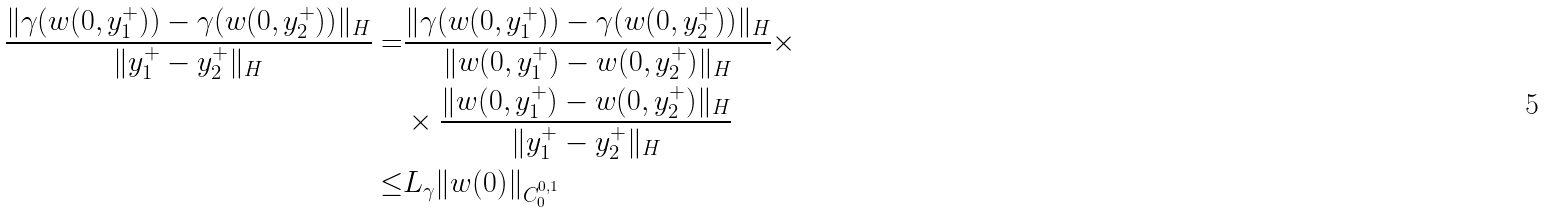<formula> <loc_0><loc_0><loc_500><loc_500>\frac { \| \gamma ( w ( 0 , y _ { 1 } ^ { + } ) ) - \gamma ( w ( 0 , y _ { 2 } ^ { + } ) ) \| _ { H } } { \| y _ { 1 } ^ { + } - y _ { 2 } ^ { + } \| _ { H } } = & \frac { \| \gamma ( w ( 0 , y _ { 1 } ^ { + } ) ) - \gamma ( w ( 0 , y _ { 2 } ^ { + } ) ) \| _ { H } } { \| w ( 0 , y _ { 1 } ^ { + } ) - w ( 0 , y _ { 2 } ^ { + } ) \| _ { H } } \times \\ & \times \frac { \| w ( 0 , y _ { 1 } ^ { + } ) - w ( 0 , y _ { 2 } ^ { + } ) \| _ { H } } { \| y _ { 1 } ^ { + } - y _ { 2 } ^ { + } \| _ { H } } \\ \leq & L _ { \gamma } \| w ( 0 ) \| _ { C _ { 0 } ^ { 0 , 1 } }</formula> 